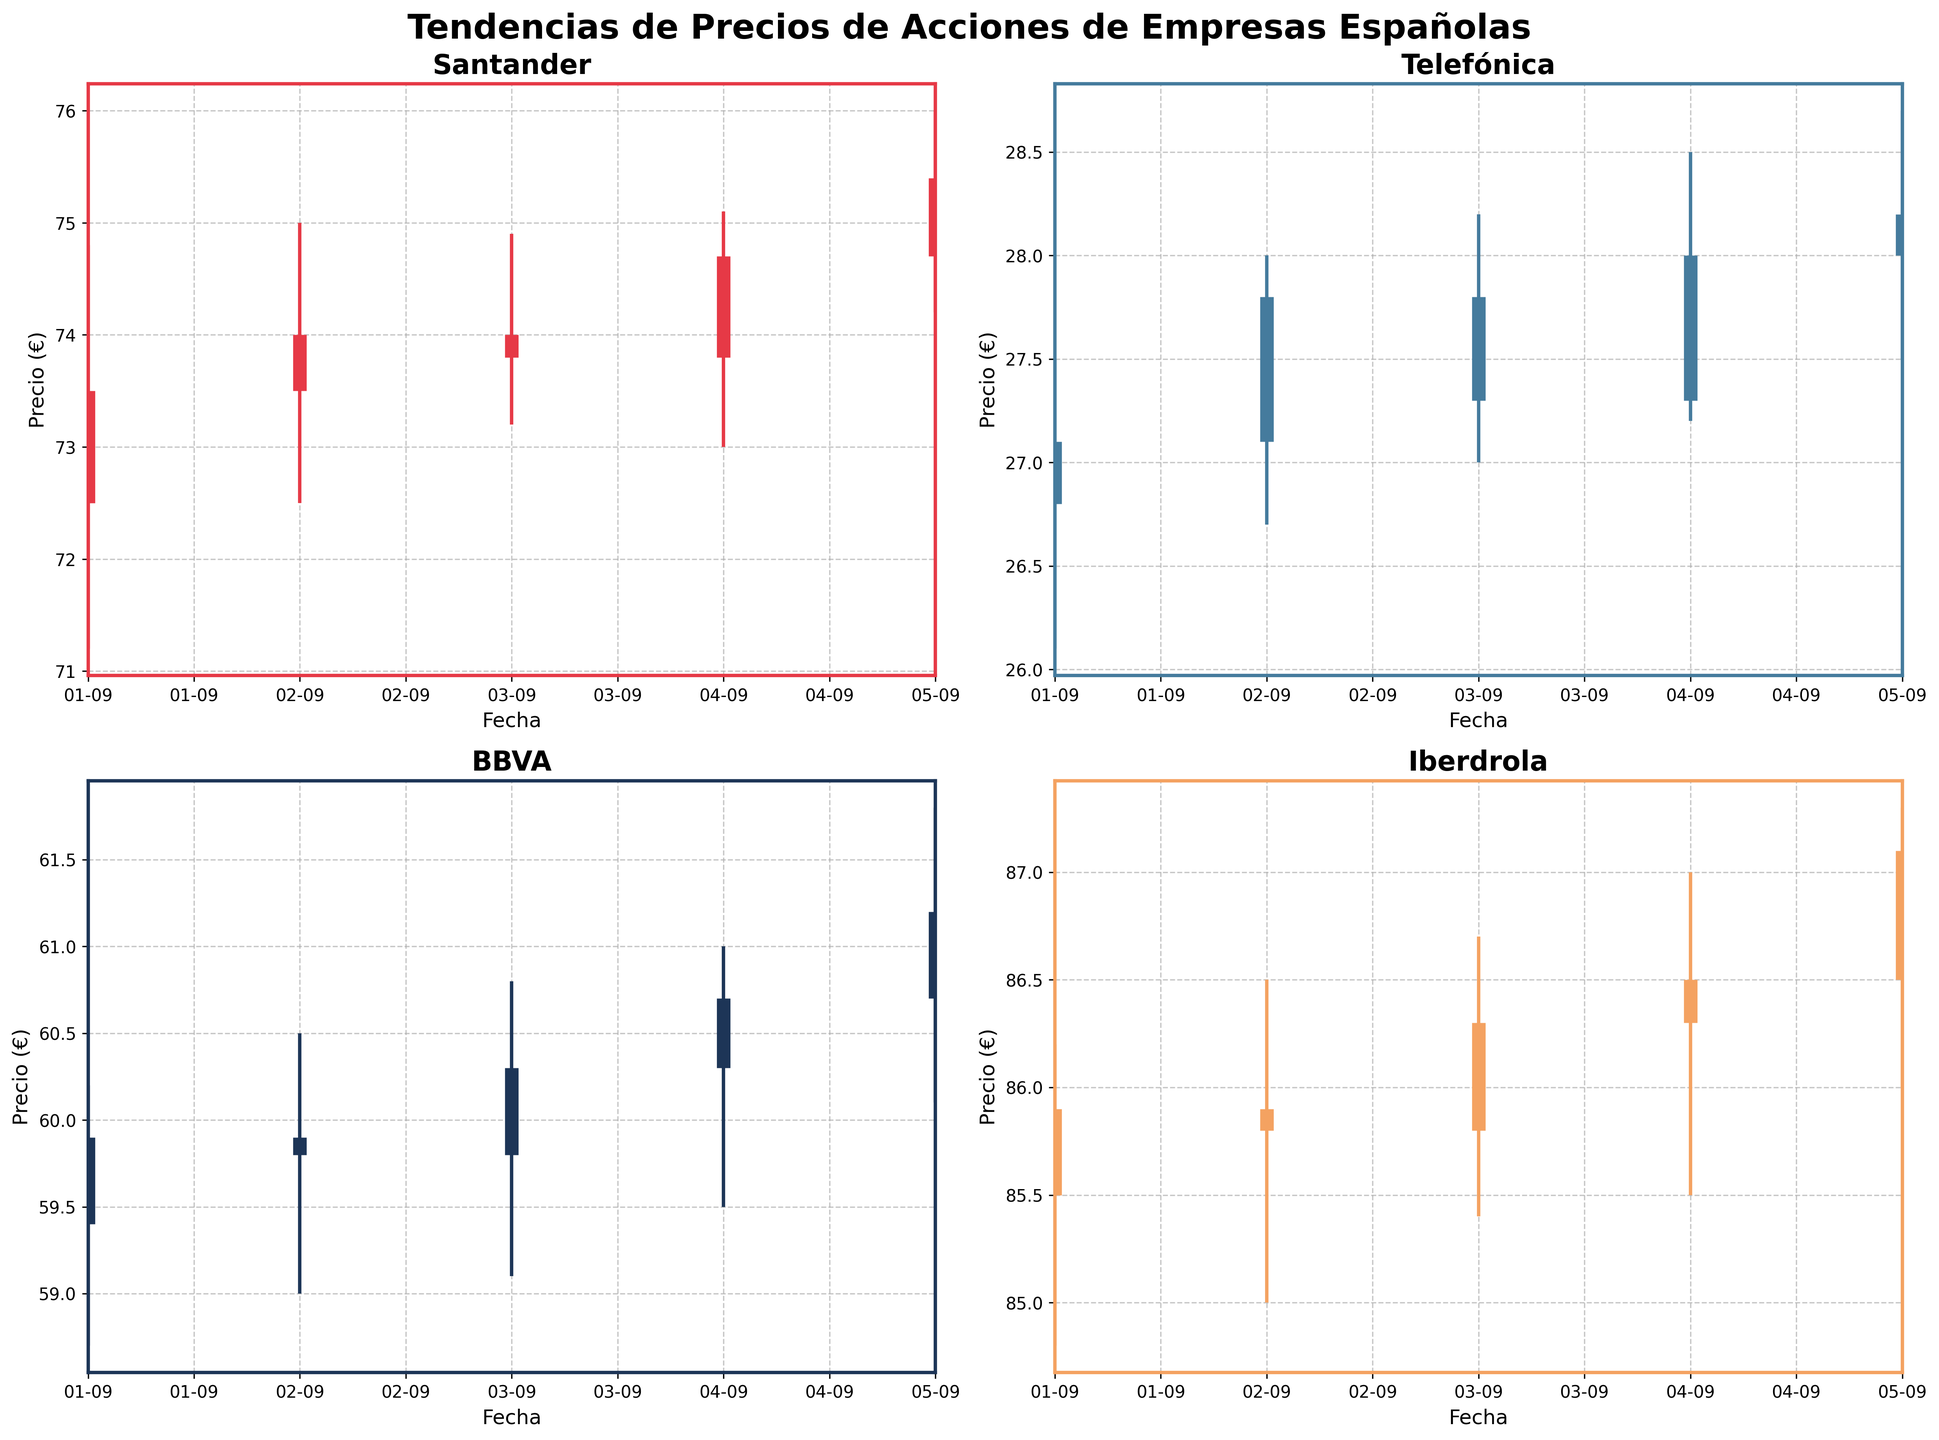¿Cuál es el título del gráfico? El título del gráfico está en la parte superior central del gráfico y dice "Tendencias de Precios de Acciones de Empresas Españolas".
Answer: Tendencias de Precios de Acciones de Empresas Españolas ¿Cuál es el precio más alto alcanzado por las acciones de Santander? El precio más alto se puede ver en el eje vertical (Precio) en el gráfico de Santander. El pico más alto es de 76.0 euros el 5 de septiembre.
Answer: 76.0 euros ¿Cuáles son las fechas en las que Iberdrola alcanzó su precio de cierre más alto y más bajo? Mirando el gráfico de Iberdrola, el precio de cierre más alto es 87.1 euros el 5 de septiembre y el más bajo es 85.8 euros el 2 de septiembre.
Answer: 5 de septiembre y 2 de septiembre ¿Cómo se compara el precio de cierre de BBVA el 4 de septiembre con el de Telefónica el mismo día? En los gráficos de BBVA y Telefónica, los precios de cierre el 4 de septiembre son 60.7 euros para BBVA y 28.0 euros para Telefónica, por lo que BBVA tiene un precio de cierre más alto.
Answer: BBVA tiene un precio de cierre más alto ¿Cuál empresa mostró la mayor variación entre los precios más bajos y más altos durante el período? La variación se puede ver observando las líneas verticales en cada gráfico. BBVA tiene la mayor diferencia entre 59.0 euros (mínimo el 2 de septiembre) y 61.8 euros (máximo el 5 de septiembre), que es una variación de 2.8 euros.
Answer: BBVA ¿Cómo cambió el precio de cierre de Telefónica del 1 al 5 de septiembre? Observando el gráfico de Telefónica, el precio de cierre aumentó de 27.1 euros el 1 de septiembre a 28.2 euros el 5 de septiembre.
Answer: Aumentó ¿Cuál día tuvo BBVA el precio de apertura más bajo? Mirando el gráfico de BBVA, el precio de apertura más bajo fue de 59.4 euros el 1 de septiembre.
Answer: 1 de septiembre Comparando los gráficos, ¿cuál empresa tendió a tener precios de apertura más altos? Comparando los precios de apertura dados en los gráficos, Iberdrola suele tener los precios de apertura más altos, todos superiores a 85 euros.
Answer: Iberdrola ¿Cuál es la diferencia promedio entre los precios más altos y más bajos para Santander durante el período? Sumar las diferencias diarias (74.8-71.2, 75.0-72.5, 74.9-73.2, 75.1-73.0, 76.0-74.2) y dividir por 5. (3.6+2.5+1.7+2.1+1.8)/5=2.34 euros.
Answer: 2.34 euros 